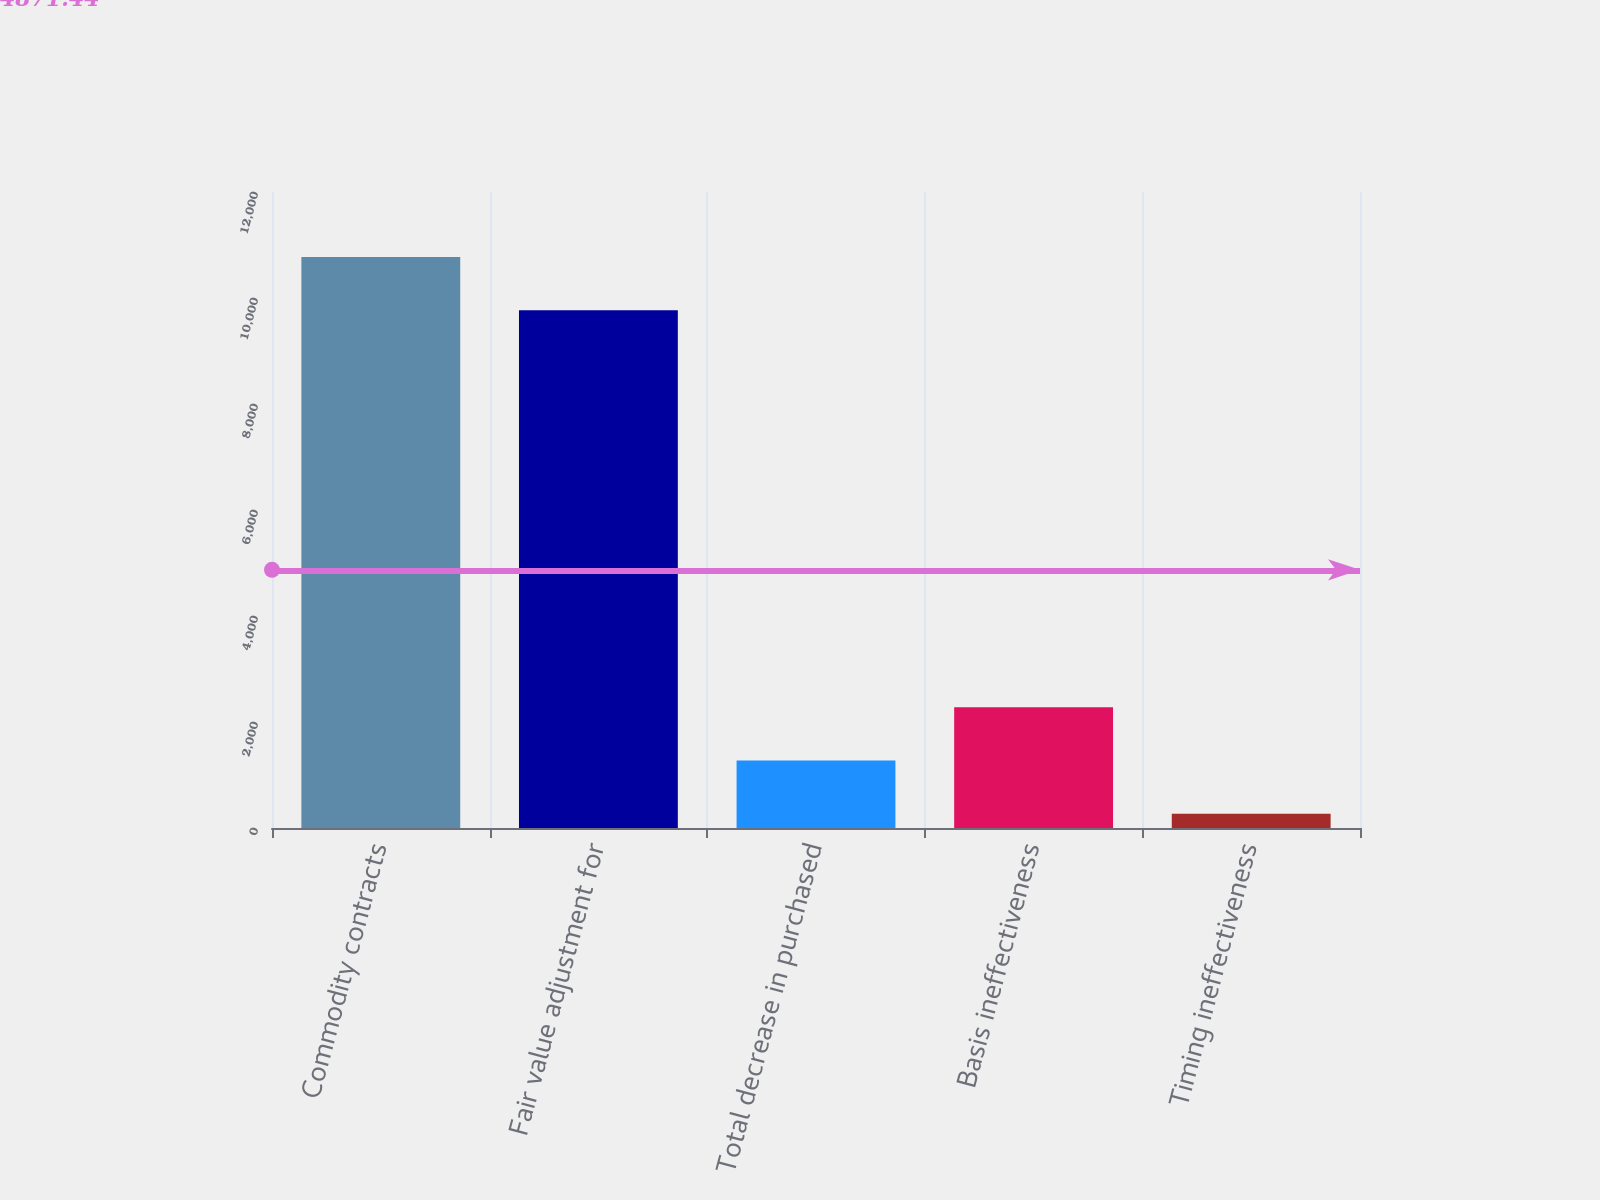Convert chart. <chart><loc_0><loc_0><loc_500><loc_500><bar_chart><fcel>Commodity contracts<fcel>Fair value adjustment for<fcel>Total decrease in purchased<fcel>Basis ineffectiveness<fcel>Timing ineffectiveness<nl><fcel>10772.3<fcel>9768<fcel>1272.3<fcel>2276.6<fcel>268<nl></chart> 